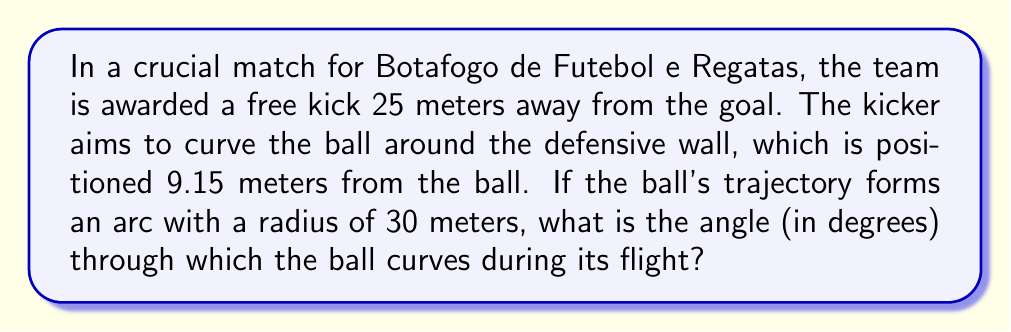Can you answer this question? Let's approach this step-by-step:

1) We can model this situation as a sector of a circle, where:
   - The radius of the circle (trajectory) is 30 meters
   - The straight-line distance from the ball to the goal is 25 meters
   - The distance to the wall is 9.15 meters

2) We need to find the central angle of this sector. Let's call this angle $\theta$.

3) We can split the sector into two right triangles:
   - One triangle has a hypotenuse of 30m and a side of 25m
   - The other has a hypotenuse of 30m and a side of (30 - 9.15) = 20.85m

4) For the first triangle, we can use the cosine function:
   $$\cos(\frac{\theta}{2}) = \frac{25}{30}$$

5) For the second triangle:
   $$\cos(\frac{\theta}{2}) = \frac{20.85}{30}$$

6) We're interested in the first equation. Let's solve for $\theta$:
   $$\frac{\theta}{2} = \arccos(\frac{25}{30})$$
   $$\theta = 2 \cdot \arccos(\frac{25}{30})$$

7) Calculate:
   $$\theta = 2 \cdot \arccos(\frac{25}{30}) \approx 2 \cdot 0.4636 \approx 0.9272 \text{ radians}$$

8) Convert to degrees:
   $$\theta \approx 0.9272 \cdot \frac{180}{\pi} \approx 53.13°$$

Therefore, the ball curves through an angle of approximately 53.13°.
Answer: $53.13°$ 